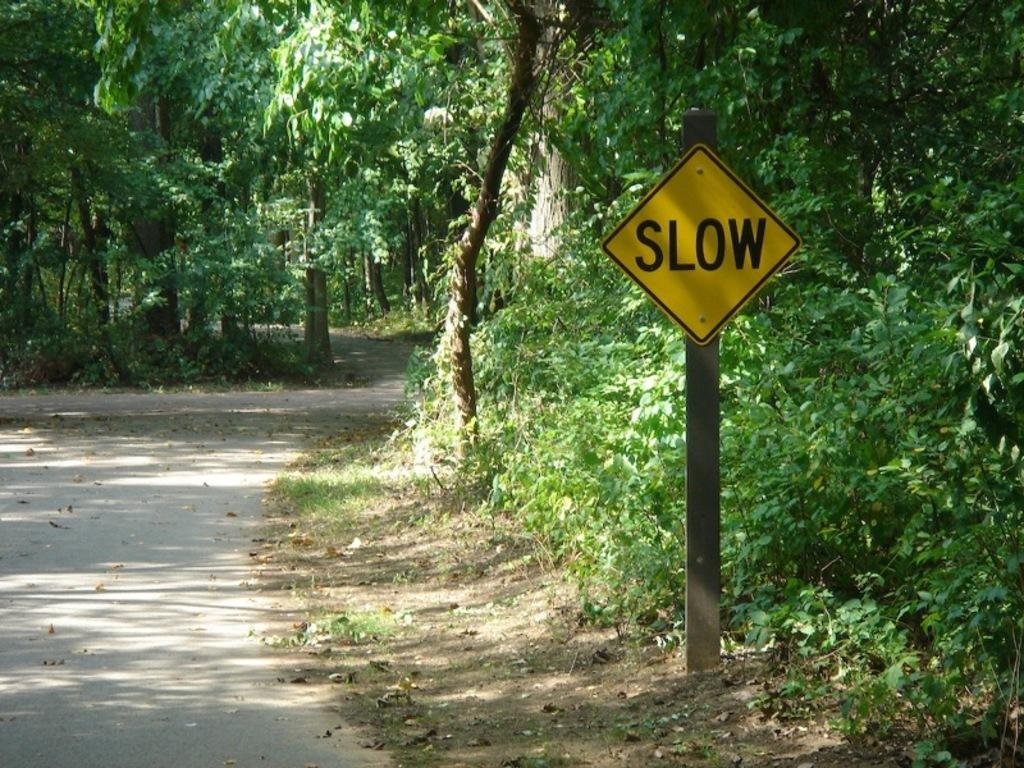What type of vegetation can be seen in the image? There are trees in the image. What structure is present in the image? There is a pole in the image. What surface is visible in the image? There is a board in the image. What type of ground is visible in the image? There is grass in the image, and soil is visible at the bottom. What type of rifle is leaning against the pole in the image? There is no rifle present in the image; only trees, a pole, a board, grass, and soil are visible. What type of flooring is visible in the image? There is no flooring visible in the image, as it appears to be an outdoor scene with grass and soil. 